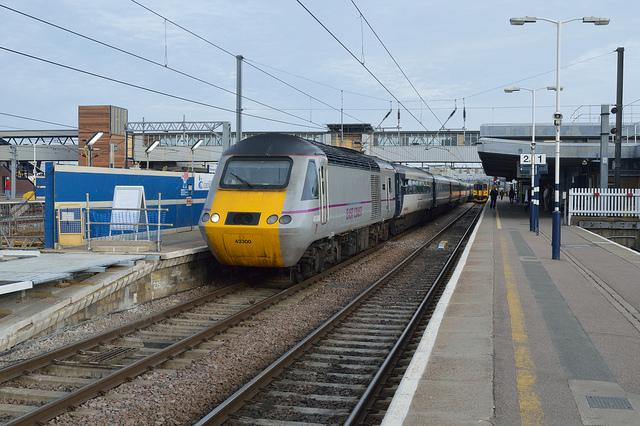Which train is safest to board for those on our right?

Choices:
A) near arriving
B) gray furthest
C) none
D) any near arriving 